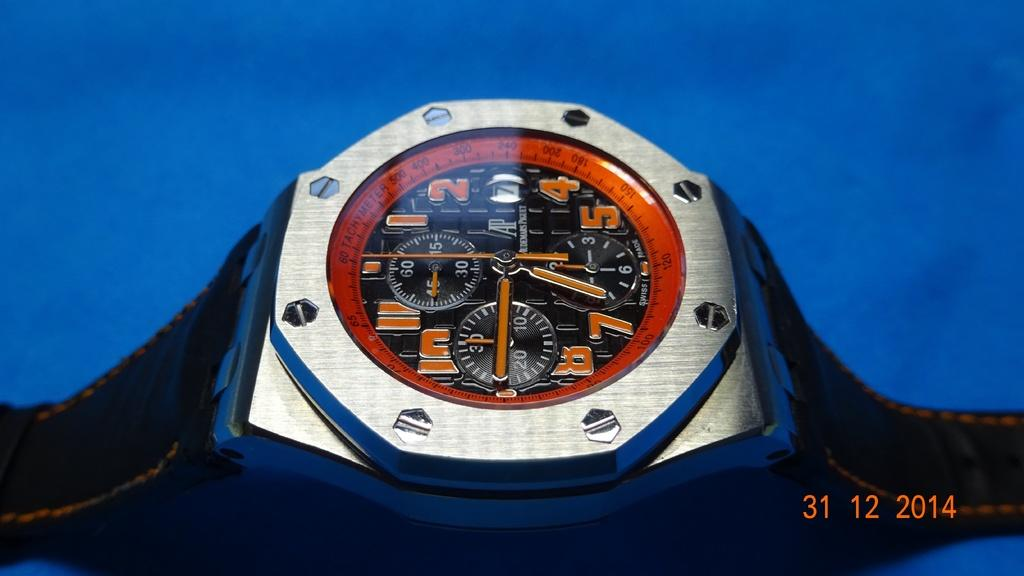<image>
Present a compact description of the photo's key features. A busy watch face tells the time at around 6:45. 